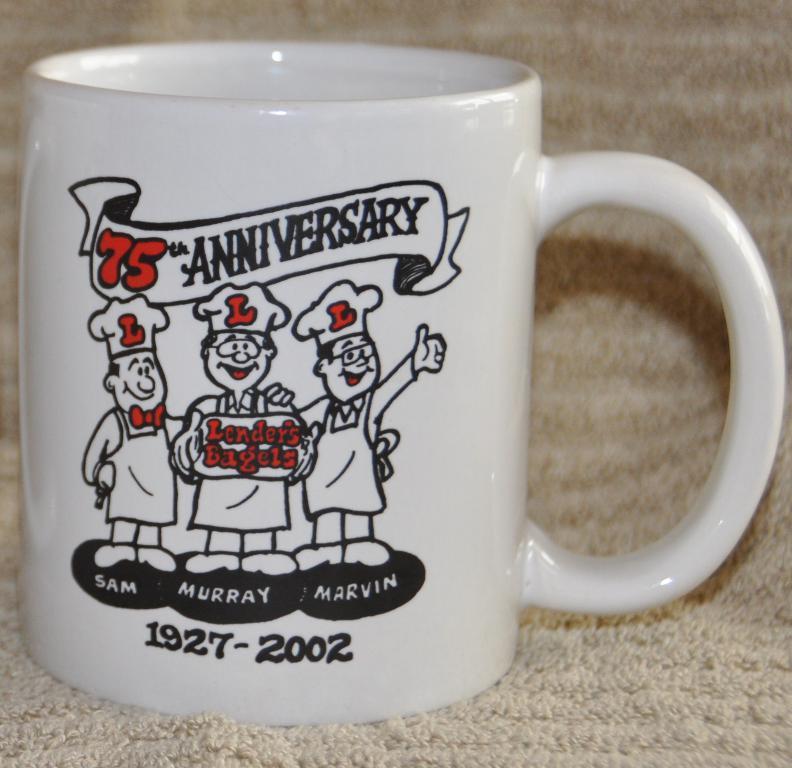Please provide a concise description of this image. In this picture I can see there is a cup placed on the carpet and the cup is in white color and there is something written on it and there is a picture of three persons wearing aprons and toques. 